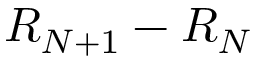Convert formula to latex. <formula><loc_0><loc_0><loc_500><loc_500>R _ { N + 1 } - R _ { N }</formula> 